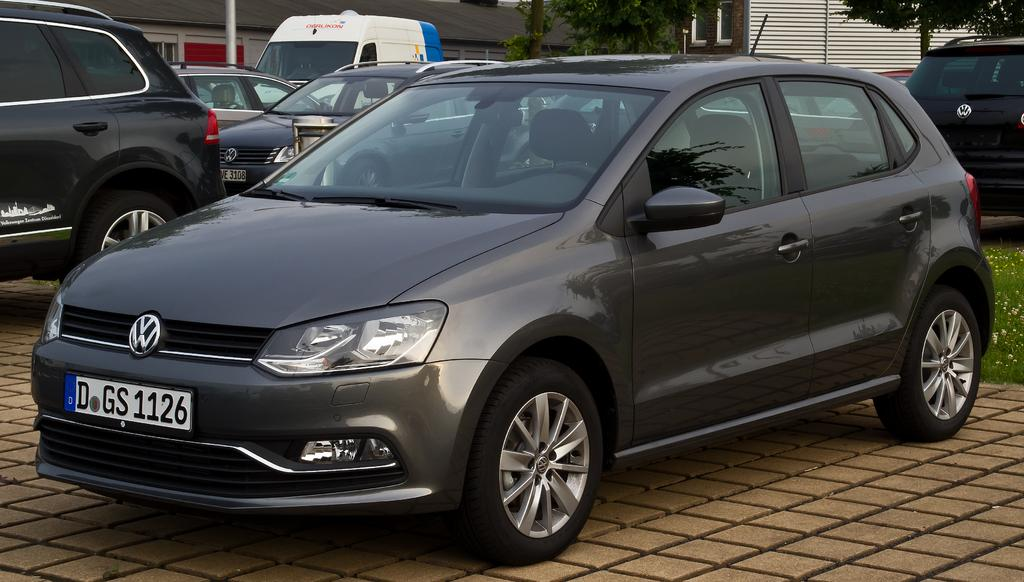What can be seen on the path in the image? There are vehicles on the path in the image. What type of vegetation is present on the ground in the image? There is grass on the ground in the image. What can be seen in the background of the image? There are trees visible in the image. What type of structures are present in the image? There are buildings in the image. What other objects can be seen in the image besides vehicles, grass, trees, and buildings? There are other objects present in the image. Where is the garden located in the image? There is no garden present in the image. What type of badge is being worn by the person in the image? There is no person or badge present in the image. 